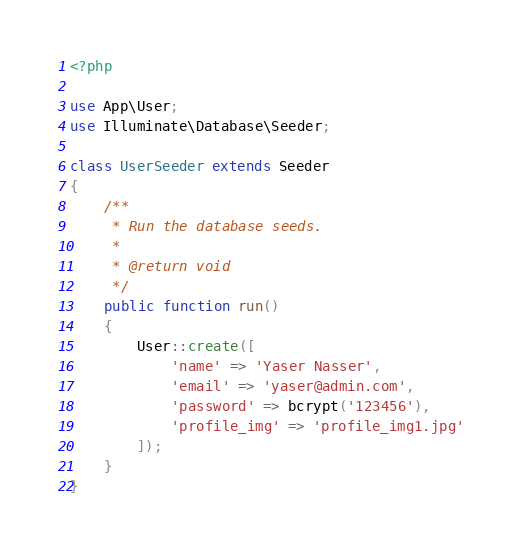Convert code to text. <code><loc_0><loc_0><loc_500><loc_500><_PHP_><?php

use App\User;
use Illuminate\Database\Seeder;

class UserSeeder extends Seeder
{
    /**
     * Run the database seeds.
     *
     * @return void
     */
    public function run()
    {
        User::create([
            'name' => 'Yaser Nasser',
            'email' => 'yaser@admin.com',
            'password' => bcrypt('123456'),
            'profile_img' => 'profile_img1.jpg'
        ]);
    }
}
</code> 